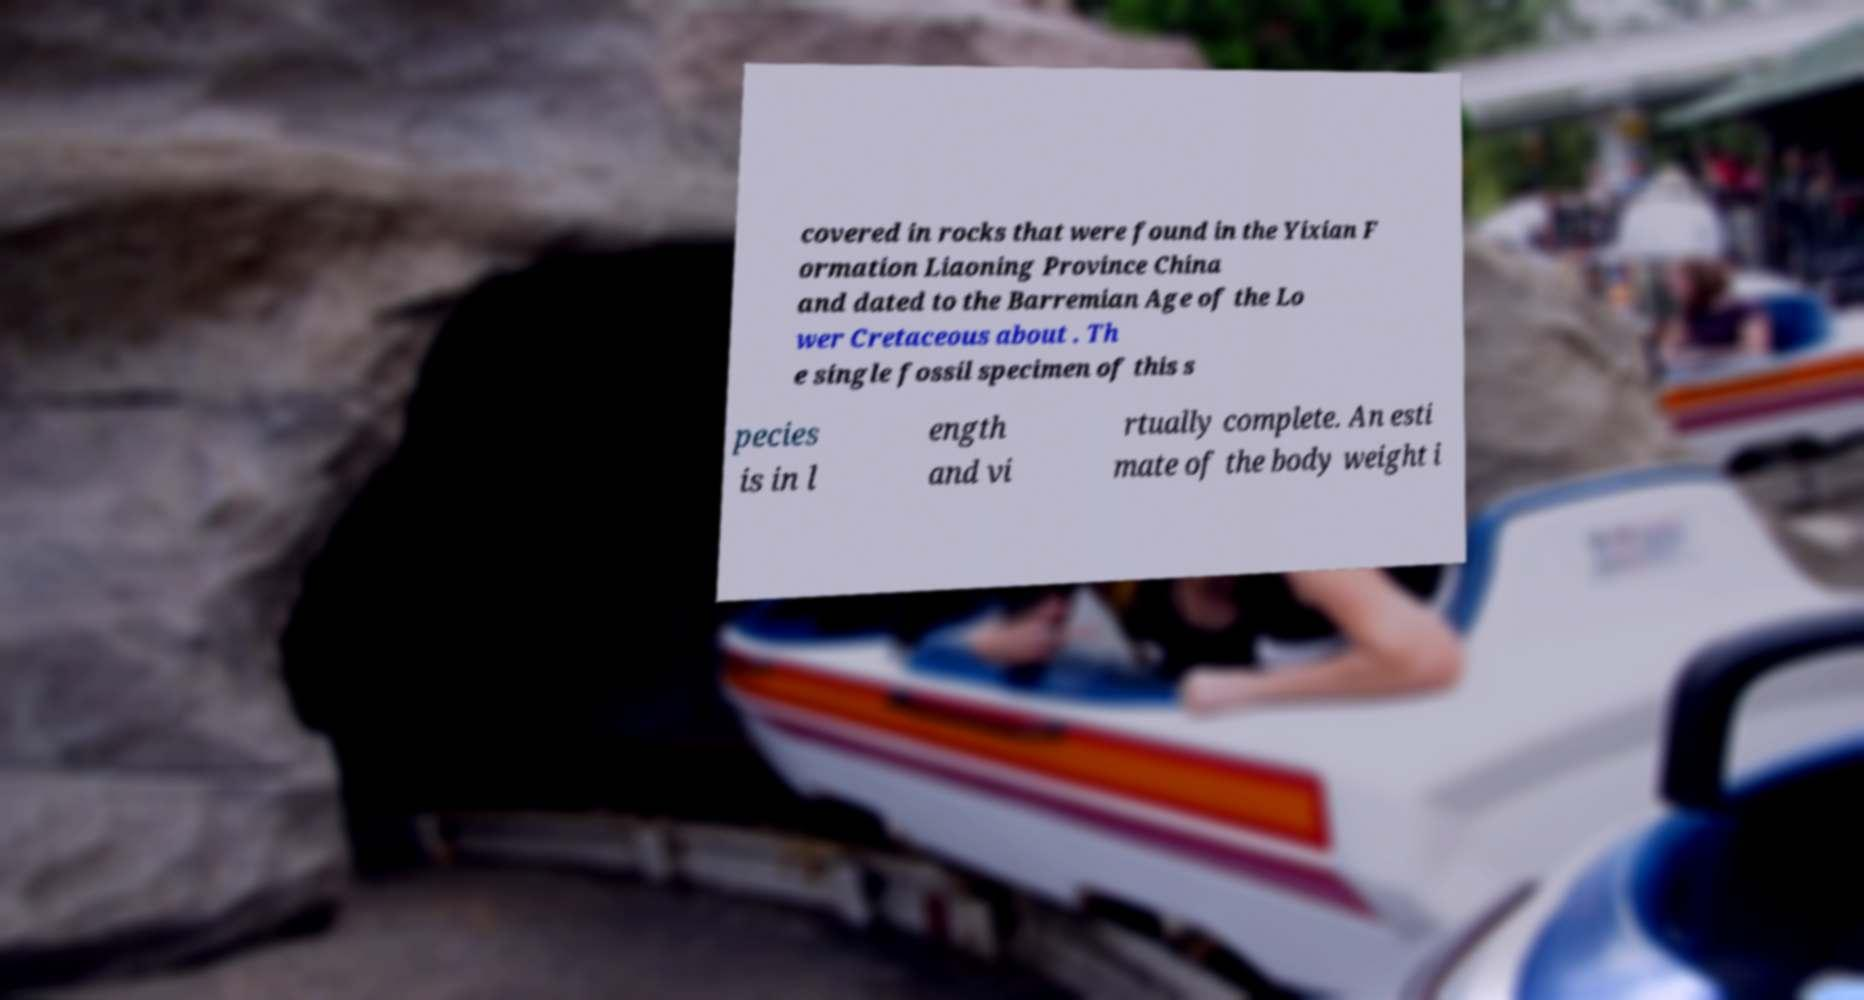Could you assist in decoding the text presented in this image and type it out clearly? covered in rocks that were found in the Yixian F ormation Liaoning Province China and dated to the Barremian Age of the Lo wer Cretaceous about . Th e single fossil specimen of this s pecies is in l ength and vi rtually complete. An esti mate of the body weight i 